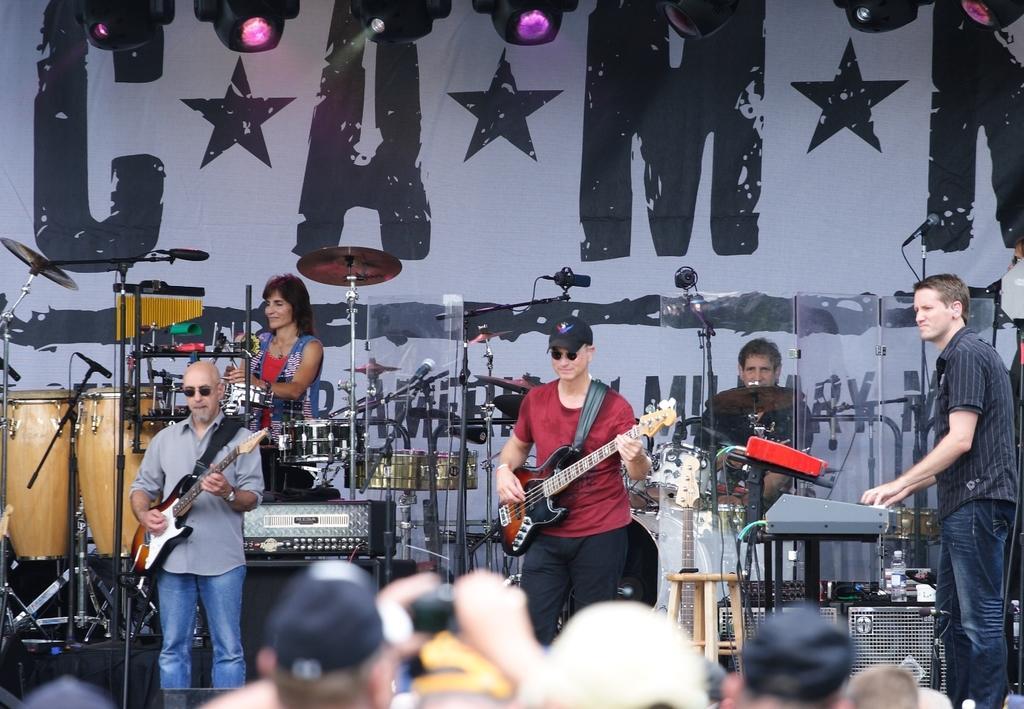Can you describe this image briefly? In this there are group of musicians performing on the stage. The woman in the background is in front of the musical instrument. The man at the left side is standing and holding a musical instrument in his hand. The person in the red shirt is holding a musical instrument and standing. At the right side the man is standing and playing a piano. At the top there are lights. In the front there are crowds enjoying the performance. 